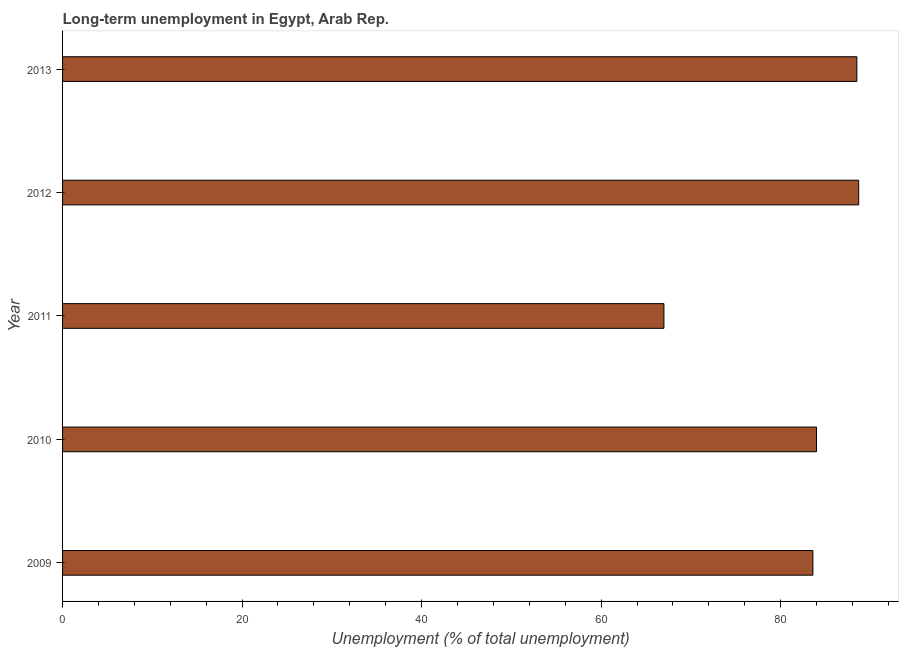Does the graph contain grids?
Your answer should be very brief. No. What is the title of the graph?
Give a very brief answer. Long-term unemployment in Egypt, Arab Rep. What is the label or title of the X-axis?
Your response must be concise. Unemployment (% of total unemployment). Across all years, what is the maximum long-term unemployment?
Make the answer very short. 88.7. Across all years, what is the minimum long-term unemployment?
Ensure brevity in your answer.  67. What is the sum of the long-term unemployment?
Provide a succinct answer. 411.8. What is the average long-term unemployment per year?
Make the answer very short. 82.36. What is the median long-term unemployment?
Your answer should be compact. 84. Do a majority of the years between 2009 and 2012 (inclusive) have long-term unemployment greater than 36 %?
Offer a very short reply. Yes. What is the ratio of the long-term unemployment in 2010 to that in 2012?
Your answer should be very brief. 0.95. Is the long-term unemployment in 2011 less than that in 2013?
Your answer should be very brief. Yes. Is the difference between the long-term unemployment in 2010 and 2011 greater than the difference between any two years?
Provide a succinct answer. No. What is the difference between the highest and the lowest long-term unemployment?
Offer a very short reply. 21.7. Are all the bars in the graph horizontal?
Keep it short and to the point. Yes. How many years are there in the graph?
Your answer should be compact. 5. What is the difference between two consecutive major ticks on the X-axis?
Your answer should be very brief. 20. What is the Unemployment (% of total unemployment) of 2009?
Keep it short and to the point. 83.6. What is the Unemployment (% of total unemployment) of 2012?
Ensure brevity in your answer.  88.7. What is the Unemployment (% of total unemployment) of 2013?
Your answer should be compact. 88.5. What is the difference between the Unemployment (% of total unemployment) in 2009 and 2011?
Your response must be concise. 16.6. What is the difference between the Unemployment (% of total unemployment) in 2009 and 2012?
Provide a succinct answer. -5.1. What is the difference between the Unemployment (% of total unemployment) in 2010 and 2012?
Make the answer very short. -4.7. What is the difference between the Unemployment (% of total unemployment) in 2010 and 2013?
Keep it short and to the point. -4.5. What is the difference between the Unemployment (% of total unemployment) in 2011 and 2012?
Ensure brevity in your answer.  -21.7. What is the difference between the Unemployment (% of total unemployment) in 2011 and 2013?
Offer a terse response. -21.5. What is the difference between the Unemployment (% of total unemployment) in 2012 and 2013?
Provide a succinct answer. 0.2. What is the ratio of the Unemployment (% of total unemployment) in 2009 to that in 2010?
Offer a terse response. 0.99. What is the ratio of the Unemployment (% of total unemployment) in 2009 to that in 2011?
Your response must be concise. 1.25. What is the ratio of the Unemployment (% of total unemployment) in 2009 to that in 2012?
Keep it short and to the point. 0.94. What is the ratio of the Unemployment (% of total unemployment) in 2009 to that in 2013?
Your response must be concise. 0.94. What is the ratio of the Unemployment (% of total unemployment) in 2010 to that in 2011?
Offer a terse response. 1.25. What is the ratio of the Unemployment (% of total unemployment) in 2010 to that in 2012?
Provide a short and direct response. 0.95. What is the ratio of the Unemployment (% of total unemployment) in 2010 to that in 2013?
Your answer should be compact. 0.95. What is the ratio of the Unemployment (% of total unemployment) in 2011 to that in 2012?
Offer a very short reply. 0.76. What is the ratio of the Unemployment (% of total unemployment) in 2011 to that in 2013?
Offer a very short reply. 0.76. 